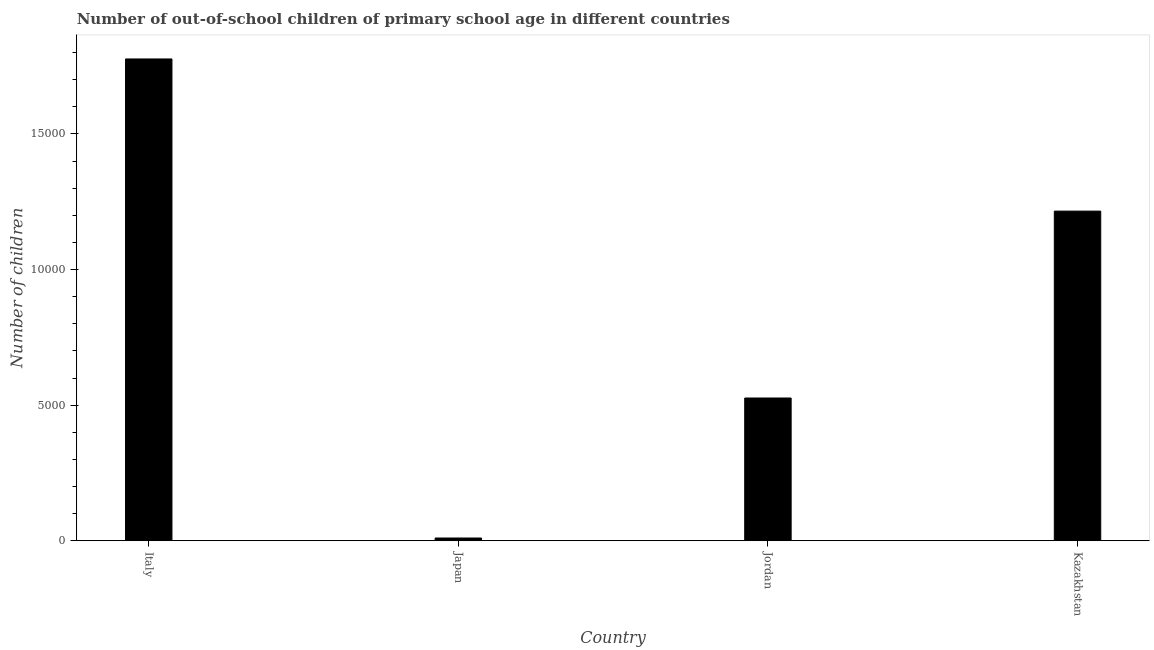Does the graph contain any zero values?
Your answer should be very brief. No. What is the title of the graph?
Provide a short and direct response. Number of out-of-school children of primary school age in different countries. What is the label or title of the Y-axis?
Your answer should be very brief. Number of children. What is the number of out-of-school children in Italy?
Provide a short and direct response. 1.78e+04. Across all countries, what is the maximum number of out-of-school children?
Provide a succinct answer. 1.78e+04. In which country was the number of out-of-school children maximum?
Ensure brevity in your answer.  Italy. What is the sum of the number of out-of-school children?
Provide a succinct answer. 3.53e+04. What is the difference between the number of out-of-school children in Japan and Kazakhstan?
Keep it short and to the point. -1.21e+04. What is the average number of out-of-school children per country?
Your answer should be very brief. 8821. What is the median number of out-of-school children?
Ensure brevity in your answer.  8709. What is the ratio of the number of out-of-school children in Japan to that in Kazakhstan?
Make the answer very short. 0.01. Is the number of out-of-school children in Italy less than that in Kazakhstan?
Offer a very short reply. No. Is the difference between the number of out-of-school children in Japan and Kazakhstan greater than the difference between any two countries?
Offer a very short reply. No. What is the difference between the highest and the second highest number of out-of-school children?
Offer a terse response. 5611. Is the sum of the number of out-of-school children in Japan and Jordan greater than the maximum number of out-of-school children across all countries?
Your answer should be compact. No. What is the difference between the highest and the lowest number of out-of-school children?
Ensure brevity in your answer.  1.77e+04. How many bars are there?
Offer a terse response. 4. Are all the bars in the graph horizontal?
Make the answer very short. No. What is the difference between two consecutive major ticks on the Y-axis?
Your response must be concise. 5000. Are the values on the major ticks of Y-axis written in scientific E-notation?
Provide a succinct answer. No. What is the Number of children of Italy?
Keep it short and to the point. 1.78e+04. What is the Number of children of Jordan?
Provide a short and direct response. 5263. What is the Number of children of Kazakhstan?
Make the answer very short. 1.22e+04. What is the difference between the Number of children in Italy and Japan?
Ensure brevity in your answer.  1.77e+04. What is the difference between the Number of children in Italy and Jordan?
Offer a terse response. 1.25e+04. What is the difference between the Number of children in Italy and Kazakhstan?
Offer a terse response. 5611. What is the difference between the Number of children in Japan and Jordan?
Give a very brief answer. -5163. What is the difference between the Number of children in Japan and Kazakhstan?
Ensure brevity in your answer.  -1.21e+04. What is the difference between the Number of children in Jordan and Kazakhstan?
Your answer should be very brief. -6892. What is the ratio of the Number of children in Italy to that in Japan?
Provide a succinct answer. 177.66. What is the ratio of the Number of children in Italy to that in Jordan?
Provide a short and direct response. 3.38. What is the ratio of the Number of children in Italy to that in Kazakhstan?
Provide a succinct answer. 1.46. What is the ratio of the Number of children in Japan to that in Jordan?
Your response must be concise. 0.02. What is the ratio of the Number of children in Japan to that in Kazakhstan?
Keep it short and to the point. 0.01. What is the ratio of the Number of children in Jordan to that in Kazakhstan?
Your answer should be compact. 0.43. 